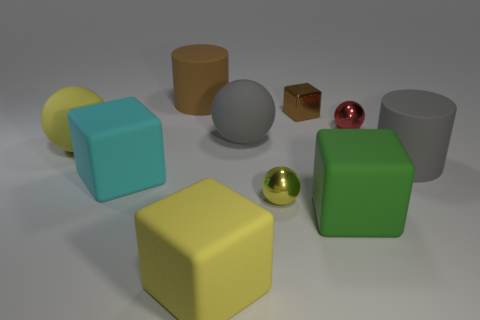Subtract all spheres. How many objects are left? 6 Add 6 gray spheres. How many gray spheres exist? 7 Subtract 0 purple spheres. How many objects are left? 10 Subtract all yellow rubber objects. Subtract all gray rubber cylinders. How many objects are left? 7 Add 9 small red metallic objects. How many small red metallic objects are left? 10 